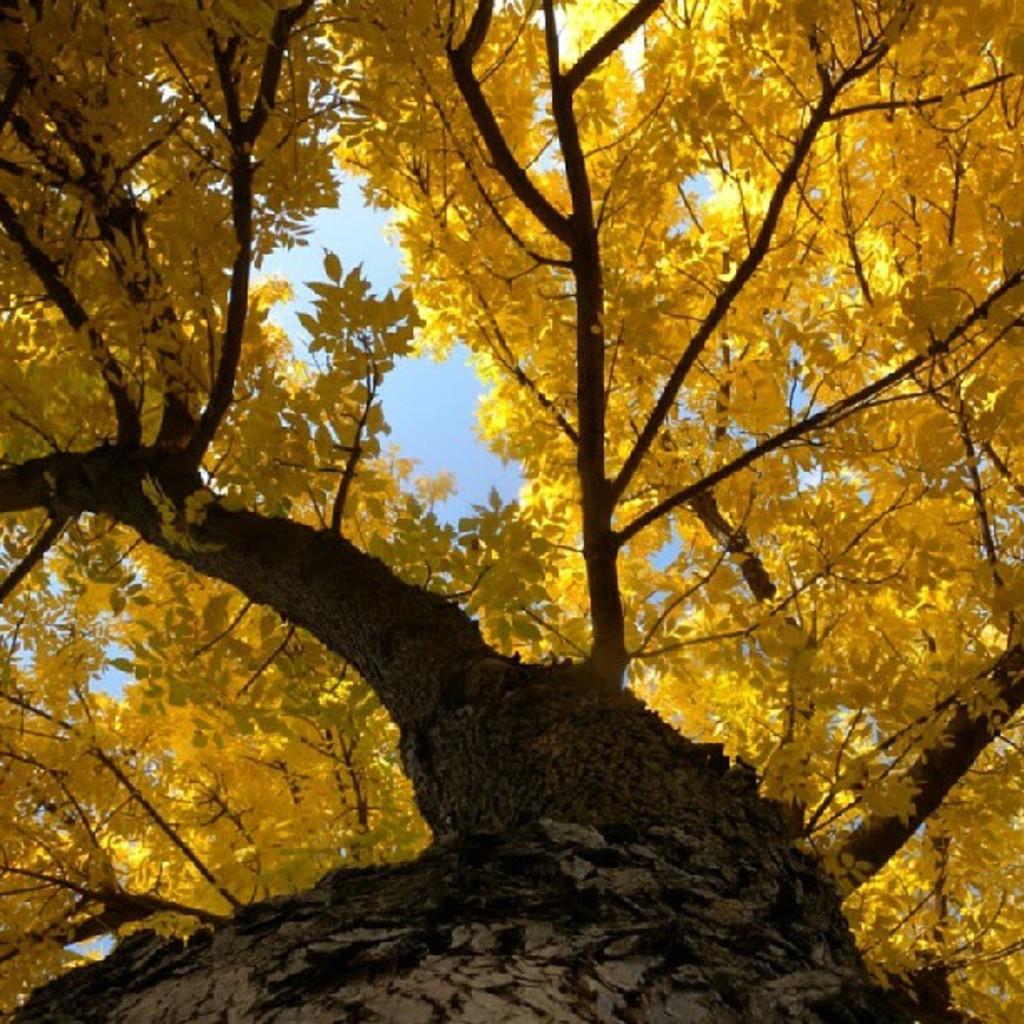Can you describe this image briefly? In this picture we can see a tree. 